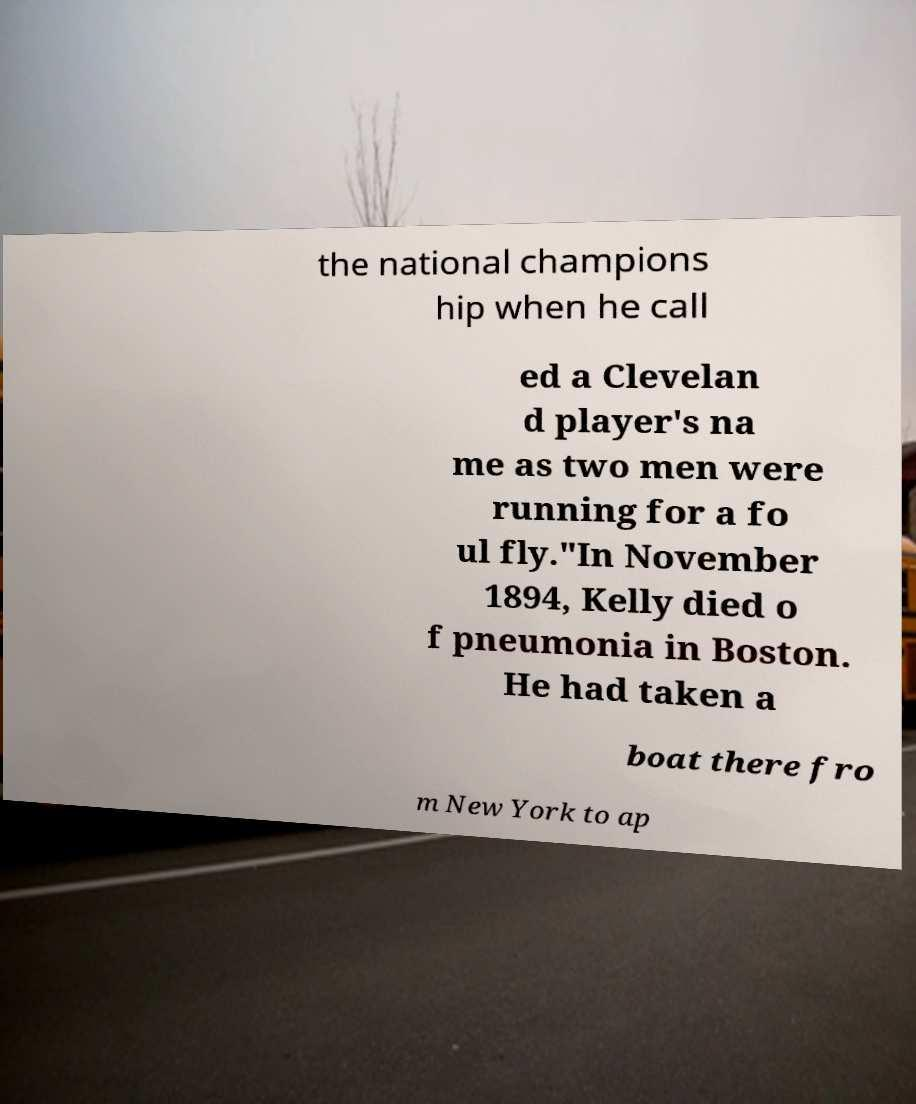There's text embedded in this image that I need extracted. Can you transcribe it verbatim? the national champions hip when he call ed a Clevelan d player's na me as two men were running for a fo ul fly."In November 1894, Kelly died o f pneumonia in Boston. He had taken a boat there fro m New York to ap 